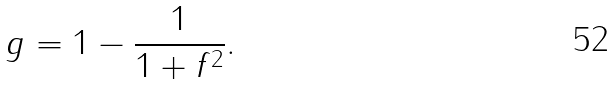<formula> <loc_0><loc_0><loc_500><loc_500>g = 1 - \frac { 1 } { 1 + f ^ { 2 } } .</formula> 